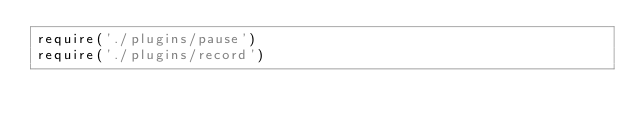Convert code to text. <code><loc_0><loc_0><loc_500><loc_500><_JavaScript_>require('./plugins/pause')
require('./plugins/record')
</code> 